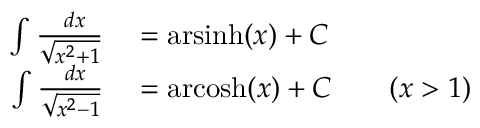<formula> <loc_0><loc_0><loc_500><loc_500>\begin{array} { r l } { \int { \frac { \ d x } { \sqrt { x ^ { 2 } + 1 } } } } & = { a r \sinh } ( x ) + C } \\ { \int { \frac { \ d x } { \sqrt { x ^ { 2 } - 1 } } } } & = { a r \cosh } ( x ) + C \quad ( x > 1 ) } \end{array}</formula> 